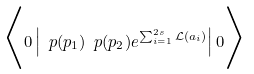Convert formula to latex. <formula><loc_0><loc_0><loc_500><loc_500>\Big < 0 \left | \ p ( p _ { 1 } ) \ p ( p _ { 2 } ) e ^ { \sum _ { i = 1 } ^ { 2 s } \mathcal { L } ( a _ { i } ) } \right | 0 \Big ></formula> 